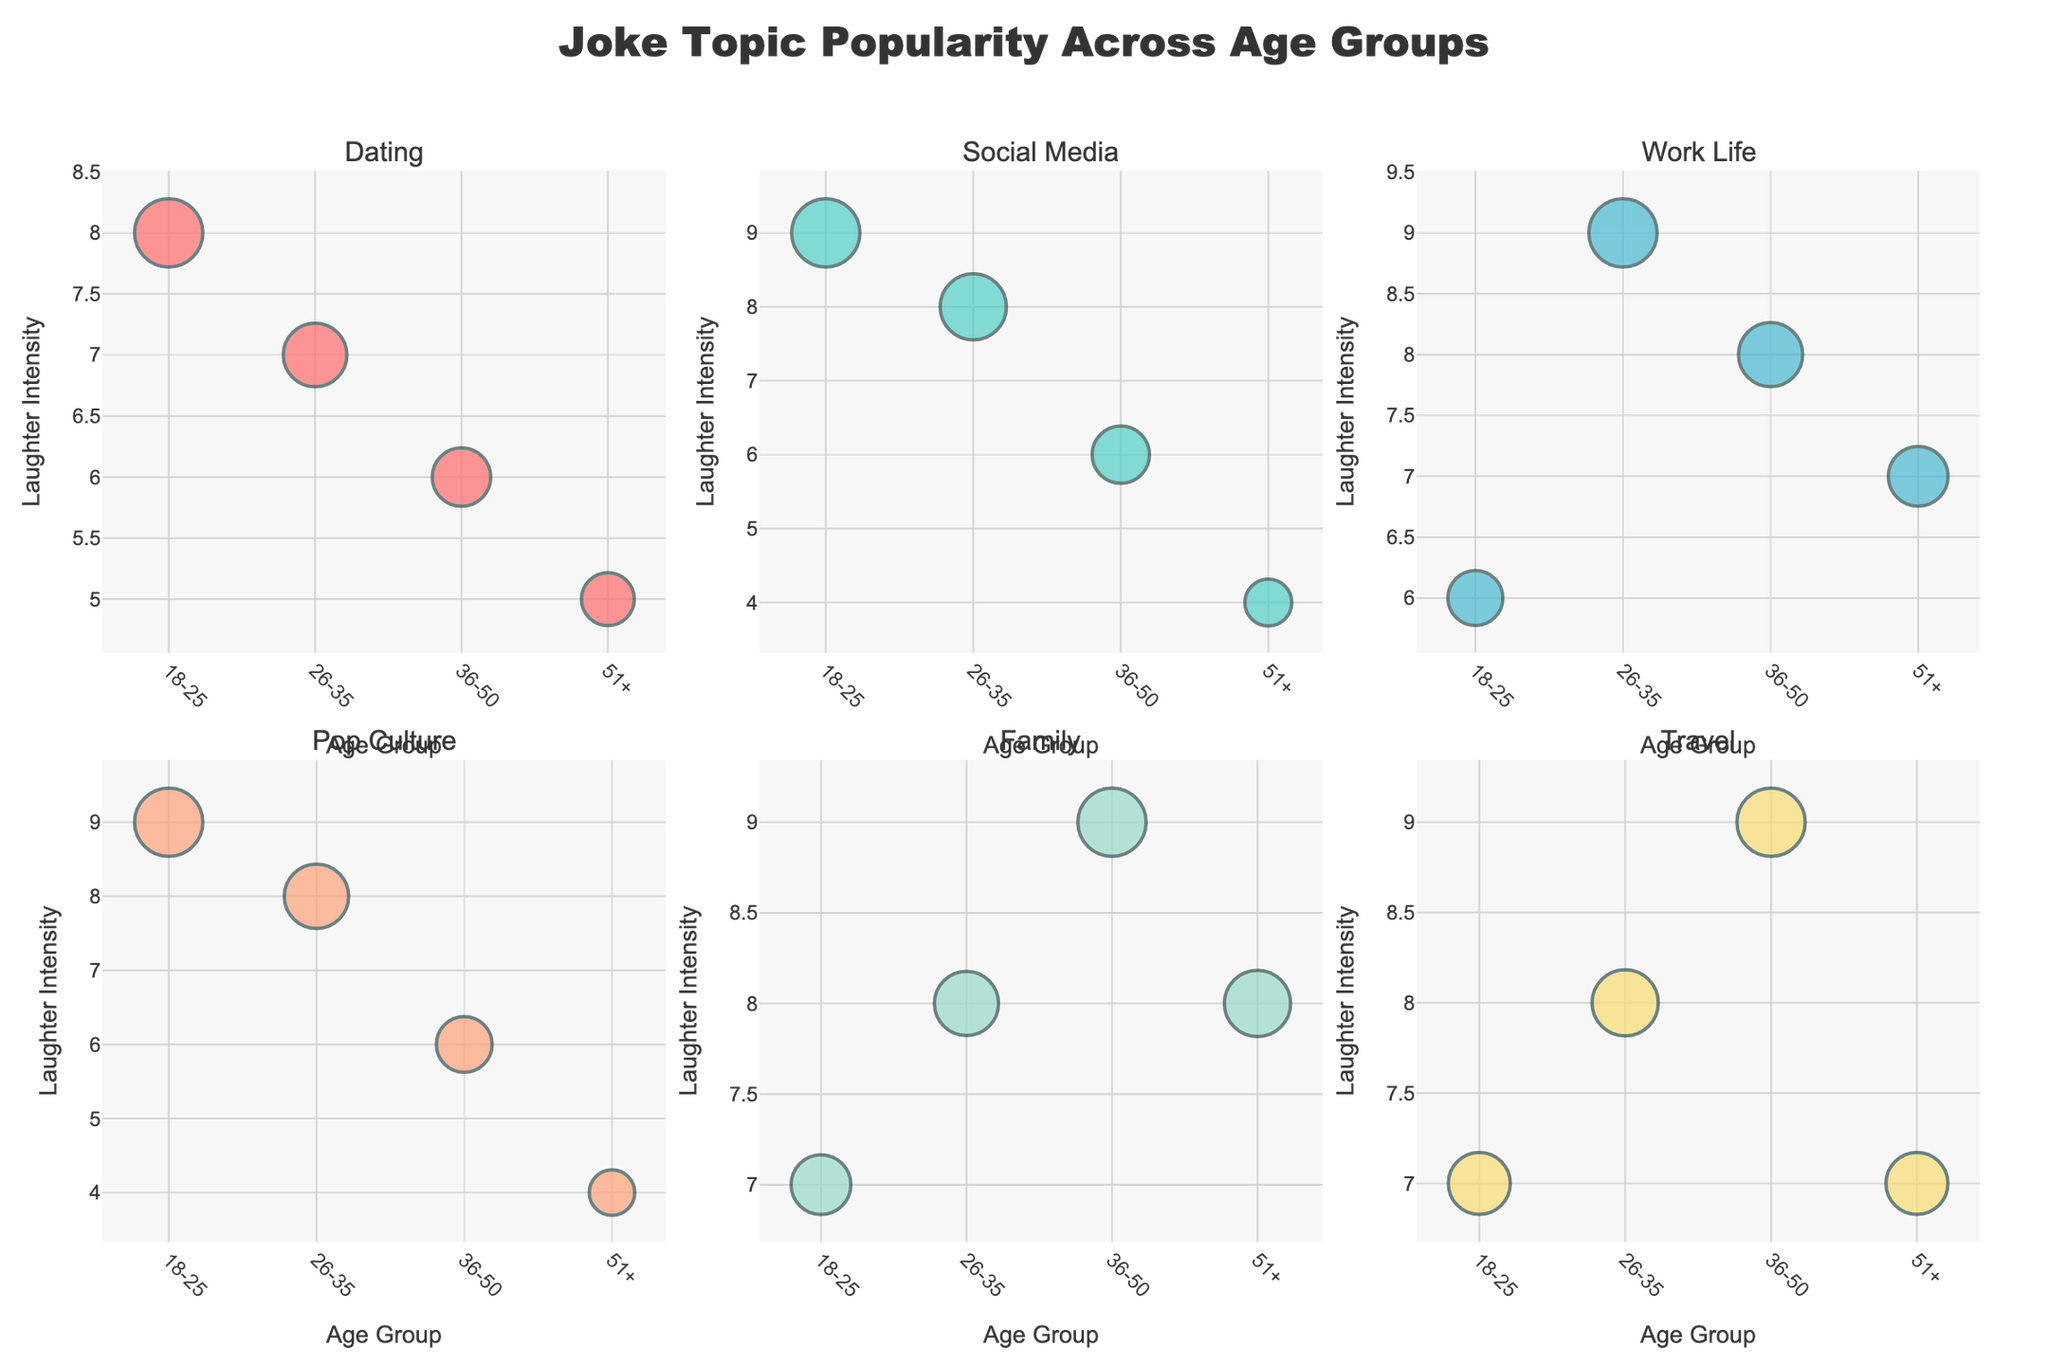What is the title of the figure? The title of the figure is displayed at the top center.
Answer: "Joke Topic Popularity Across Age Groups" Which topic has the highest laughter intensity for the 18-25 age group? Look at the bubbles in the plot for the 18-25 age group across all subplots and compare their laughter intensity values.
Answer: Pop Culture How does the laughter intensity of "Family" jokes change with age? Observe the bubbles in the "Family" subplot for each age group and note the laughter intensity values. The values increase from 7 (18-25), to 8 (26-35), to 9 (36-50), and then slightly decrease to 8 for 51+.
Answer: It increases with age until 36-50, then slightly decreases for 51+ Which age group finds "Social Media" jokes the least popular? Look at the size of the bubbles in the "Social Media" subplot and identify the smallest bubble across all age groups.
Answer: 51+ In the "Travel" subplot, compare the popularity of jokes between the 18-25 and 36-50 age groups. Look at the size of the bubbles in the "Travel" subplot for 18-25 and 36-50 age groups. The popularity for 18-25 is 70, while for 36-50 it is 85.
Answer: 36-50 is more popular than 18-25 What is the trend of laughter intensity in "Dating" jokes across increasing age groups? Observe the laughter intensity values for the "Dating" subplot across all age groups. Notice that values decrease as age increases.
Answer: Decreases Among all topics, which has the smallest bubble for the 51+ age group? Find the smallest bubble across all subplots specifically for the 51+ age group based on the size of the bubbles.
Answer: Social Media How does the popularity of "Work Life" jokes vary between the 26-35 and 51+ age groups? Compare the size of the bubbles in the "Work Life" subplot for the 26-35 and 51+ age groups. The popularity for 26-35 is 85, while for 51+ it is 65.
Answer: 26-35 is more popular than 51+ What is the highest laughter intensity value in the entire figure? Look for the highest number across all bubbles in terms of laughter intensity values, and identify the highest one which is 9.
Answer: 9 Which age group shows the highest popularity for "Travel" jokes? Look at the size of the bubbles in the "Travel" subplot and find out which age group has the largest bubble.
Answer: 36-50 